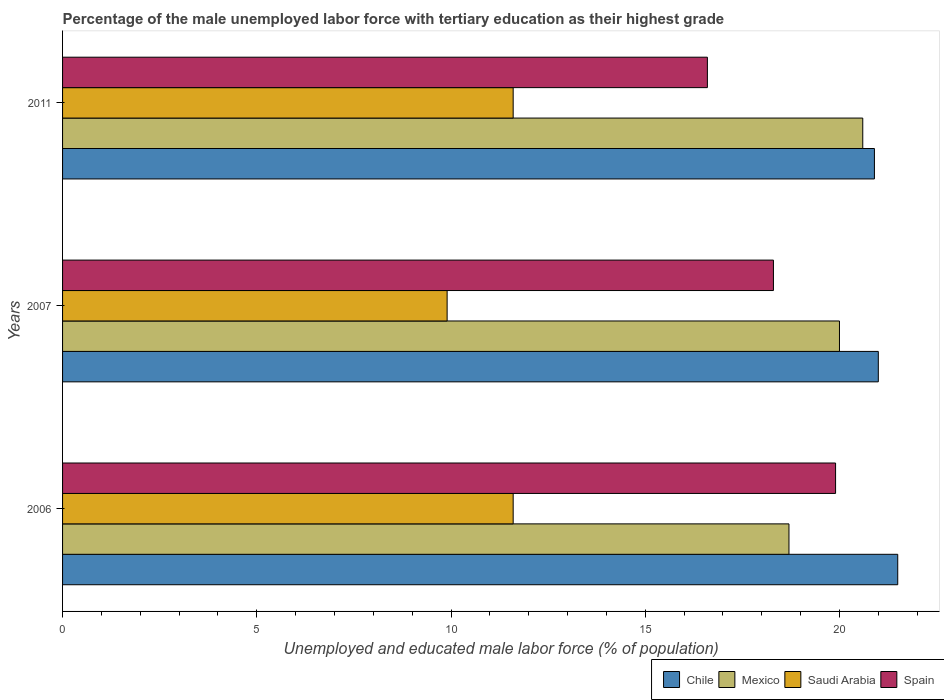How many groups of bars are there?
Provide a succinct answer. 3. Are the number of bars per tick equal to the number of legend labels?
Offer a terse response. Yes. Are the number of bars on each tick of the Y-axis equal?
Give a very brief answer. Yes. How many bars are there on the 1st tick from the bottom?
Provide a succinct answer. 4. In how many cases, is the number of bars for a given year not equal to the number of legend labels?
Provide a short and direct response. 0. What is the percentage of the unemployed male labor force with tertiary education in Mexico in 2006?
Offer a very short reply. 18.7. Across all years, what is the maximum percentage of the unemployed male labor force with tertiary education in Spain?
Your answer should be compact. 19.9. Across all years, what is the minimum percentage of the unemployed male labor force with tertiary education in Mexico?
Offer a terse response. 18.7. In which year was the percentage of the unemployed male labor force with tertiary education in Chile maximum?
Offer a very short reply. 2006. In which year was the percentage of the unemployed male labor force with tertiary education in Chile minimum?
Your answer should be compact. 2011. What is the total percentage of the unemployed male labor force with tertiary education in Saudi Arabia in the graph?
Provide a succinct answer. 33.1. What is the difference between the percentage of the unemployed male labor force with tertiary education in Saudi Arabia in 2007 and that in 2011?
Provide a short and direct response. -1.7. What is the difference between the percentage of the unemployed male labor force with tertiary education in Mexico in 2011 and the percentage of the unemployed male labor force with tertiary education in Spain in 2007?
Your answer should be compact. 2.3. What is the average percentage of the unemployed male labor force with tertiary education in Chile per year?
Provide a succinct answer. 21.13. What is the ratio of the percentage of the unemployed male labor force with tertiary education in Mexico in 2006 to that in 2011?
Keep it short and to the point. 0.91. Is the percentage of the unemployed male labor force with tertiary education in Saudi Arabia in 2007 less than that in 2011?
Offer a very short reply. Yes. Is the difference between the percentage of the unemployed male labor force with tertiary education in Chile in 2007 and 2011 greater than the difference between the percentage of the unemployed male labor force with tertiary education in Mexico in 2007 and 2011?
Offer a terse response. Yes. What is the difference between the highest and the second highest percentage of the unemployed male labor force with tertiary education in Spain?
Provide a short and direct response. 1.6. What is the difference between the highest and the lowest percentage of the unemployed male labor force with tertiary education in Spain?
Provide a succinct answer. 3.3. In how many years, is the percentage of the unemployed male labor force with tertiary education in Saudi Arabia greater than the average percentage of the unemployed male labor force with tertiary education in Saudi Arabia taken over all years?
Keep it short and to the point. 2. Is the sum of the percentage of the unemployed male labor force with tertiary education in Mexico in 2006 and 2011 greater than the maximum percentage of the unemployed male labor force with tertiary education in Spain across all years?
Give a very brief answer. Yes. What does the 4th bar from the top in 2006 represents?
Your response must be concise. Chile. What does the 4th bar from the bottom in 2011 represents?
Your response must be concise. Spain. How many bars are there?
Your answer should be very brief. 12. Are all the bars in the graph horizontal?
Make the answer very short. Yes. How many years are there in the graph?
Provide a succinct answer. 3. Does the graph contain any zero values?
Offer a very short reply. No. How many legend labels are there?
Provide a short and direct response. 4. What is the title of the graph?
Keep it short and to the point. Percentage of the male unemployed labor force with tertiary education as their highest grade. Does "Guinea" appear as one of the legend labels in the graph?
Your response must be concise. No. What is the label or title of the X-axis?
Your answer should be very brief. Unemployed and educated male labor force (% of population). What is the label or title of the Y-axis?
Ensure brevity in your answer.  Years. What is the Unemployed and educated male labor force (% of population) of Chile in 2006?
Your response must be concise. 21.5. What is the Unemployed and educated male labor force (% of population) of Mexico in 2006?
Offer a terse response. 18.7. What is the Unemployed and educated male labor force (% of population) of Saudi Arabia in 2006?
Your answer should be compact. 11.6. What is the Unemployed and educated male labor force (% of population) in Spain in 2006?
Your answer should be very brief. 19.9. What is the Unemployed and educated male labor force (% of population) of Mexico in 2007?
Provide a succinct answer. 20. What is the Unemployed and educated male labor force (% of population) in Saudi Arabia in 2007?
Make the answer very short. 9.9. What is the Unemployed and educated male labor force (% of population) in Spain in 2007?
Offer a terse response. 18.3. What is the Unemployed and educated male labor force (% of population) in Chile in 2011?
Your answer should be compact. 20.9. What is the Unemployed and educated male labor force (% of population) of Mexico in 2011?
Make the answer very short. 20.6. What is the Unemployed and educated male labor force (% of population) in Saudi Arabia in 2011?
Your answer should be very brief. 11.6. What is the Unemployed and educated male labor force (% of population) in Spain in 2011?
Ensure brevity in your answer.  16.6. Across all years, what is the maximum Unemployed and educated male labor force (% of population) in Mexico?
Your response must be concise. 20.6. Across all years, what is the maximum Unemployed and educated male labor force (% of population) in Saudi Arabia?
Offer a terse response. 11.6. Across all years, what is the maximum Unemployed and educated male labor force (% of population) of Spain?
Ensure brevity in your answer.  19.9. Across all years, what is the minimum Unemployed and educated male labor force (% of population) of Chile?
Ensure brevity in your answer.  20.9. Across all years, what is the minimum Unemployed and educated male labor force (% of population) of Mexico?
Your response must be concise. 18.7. Across all years, what is the minimum Unemployed and educated male labor force (% of population) in Saudi Arabia?
Offer a terse response. 9.9. Across all years, what is the minimum Unemployed and educated male labor force (% of population) of Spain?
Your answer should be compact. 16.6. What is the total Unemployed and educated male labor force (% of population) in Chile in the graph?
Keep it short and to the point. 63.4. What is the total Unemployed and educated male labor force (% of population) in Mexico in the graph?
Make the answer very short. 59.3. What is the total Unemployed and educated male labor force (% of population) of Saudi Arabia in the graph?
Keep it short and to the point. 33.1. What is the total Unemployed and educated male labor force (% of population) of Spain in the graph?
Offer a terse response. 54.8. What is the difference between the Unemployed and educated male labor force (% of population) of Chile in 2006 and that in 2007?
Keep it short and to the point. 0.5. What is the difference between the Unemployed and educated male labor force (% of population) in Mexico in 2006 and that in 2007?
Offer a very short reply. -1.3. What is the difference between the Unemployed and educated male labor force (% of population) in Spain in 2006 and that in 2007?
Offer a terse response. 1.6. What is the difference between the Unemployed and educated male labor force (% of population) of Chile in 2006 and that in 2011?
Offer a very short reply. 0.6. What is the difference between the Unemployed and educated male labor force (% of population) in Mexico in 2006 and that in 2011?
Your answer should be compact. -1.9. What is the difference between the Unemployed and educated male labor force (% of population) in Spain in 2006 and that in 2011?
Ensure brevity in your answer.  3.3. What is the difference between the Unemployed and educated male labor force (% of population) in Mexico in 2007 and that in 2011?
Your answer should be compact. -0.6. What is the difference between the Unemployed and educated male labor force (% of population) in Spain in 2007 and that in 2011?
Your answer should be compact. 1.7. What is the difference between the Unemployed and educated male labor force (% of population) of Chile in 2006 and the Unemployed and educated male labor force (% of population) of Mexico in 2007?
Give a very brief answer. 1.5. What is the difference between the Unemployed and educated male labor force (% of population) of Chile in 2006 and the Unemployed and educated male labor force (% of population) of Saudi Arabia in 2007?
Offer a terse response. 11.6. What is the difference between the Unemployed and educated male labor force (% of population) in Mexico in 2006 and the Unemployed and educated male labor force (% of population) in Saudi Arabia in 2007?
Your answer should be very brief. 8.8. What is the difference between the Unemployed and educated male labor force (% of population) in Chile in 2006 and the Unemployed and educated male labor force (% of population) in Saudi Arabia in 2011?
Your answer should be compact. 9.9. What is the difference between the Unemployed and educated male labor force (% of population) of Chile in 2006 and the Unemployed and educated male labor force (% of population) of Spain in 2011?
Keep it short and to the point. 4.9. What is the difference between the Unemployed and educated male labor force (% of population) in Mexico in 2006 and the Unemployed and educated male labor force (% of population) in Saudi Arabia in 2011?
Offer a terse response. 7.1. What is the difference between the Unemployed and educated male labor force (% of population) of Saudi Arabia in 2006 and the Unemployed and educated male labor force (% of population) of Spain in 2011?
Your answer should be compact. -5. What is the difference between the Unemployed and educated male labor force (% of population) in Chile in 2007 and the Unemployed and educated male labor force (% of population) in Spain in 2011?
Offer a very short reply. 4.4. What is the difference between the Unemployed and educated male labor force (% of population) of Mexico in 2007 and the Unemployed and educated male labor force (% of population) of Spain in 2011?
Keep it short and to the point. 3.4. What is the difference between the Unemployed and educated male labor force (% of population) of Saudi Arabia in 2007 and the Unemployed and educated male labor force (% of population) of Spain in 2011?
Your response must be concise. -6.7. What is the average Unemployed and educated male labor force (% of population) in Chile per year?
Provide a short and direct response. 21.13. What is the average Unemployed and educated male labor force (% of population) of Mexico per year?
Provide a short and direct response. 19.77. What is the average Unemployed and educated male labor force (% of population) of Saudi Arabia per year?
Provide a short and direct response. 11.03. What is the average Unemployed and educated male labor force (% of population) of Spain per year?
Provide a short and direct response. 18.27. In the year 2006, what is the difference between the Unemployed and educated male labor force (% of population) in Chile and Unemployed and educated male labor force (% of population) in Saudi Arabia?
Your answer should be very brief. 9.9. In the year 2006, what is the difference between the Unemployed and educated male labor force (% of population) in Chile and Unemployed and educated male labor force (% of population) in Spain?
Offer a very short reply. 1.6. In the year 2006, what is the difference between the Unemployed and educated male labor force (% of population) of Mexico and Unemployed and educated male labor force (% of population) of Saudi Arabia?
Offer a very short reply. 7.1. In the year 2006, what is the difference between the Unemployed and educated male labor force (% of population) in Mexico and Unemployed and educated male labor force (% of population) in Spain?
Your response must be concise. -1.2. In the year 2007, what is the difference between the Unemployed and educated male labor force (% of population) in Chile and Unemployed and educated male labor force (% of population) in Mexico?
Give a very brief answer. 1. In the year 2007, what is the difference between the Unemployed and educated male labor force (% of population) in Chile and Unemployed and educated male labor force (% of population) in Spain?
Provide a succinct answer. 2.7. In the year 2007, what is the difference between the Unemployed and educated male labor force (% of population) of Saudi Arabia and Unemployed and educated male labor force (% of population) of Spain?
Keep it short and to the point. -8.4. In the year 2011, what is the difference between the Unemployed and educated male labor force (% of population) in Chile and Unemployed and educated male labor force (% of population) in Saudi Arabia?
Keep it short and to the point. 9.3. In the year 2011, what is the difference between the Unemployed and educated male labor force (% of population) in Chile and Unemployed and educated male labor force (% of population) in Spain?
Your response must be concise. 4.3. In the year 2011, what is the difference between the Unemployed and educated male labor force (% of population) in Mexico and Unemployed and educated male labor force (% of population) in Saudi Arabia?
Provide a short and direct response. 9. In the year 2011, what is the difference between the Unemployed and educated male labor force (% of population) of Mexico and Unemployed and educated male labor force (% of population) of Spain?
Give a very brief answer. 4. What is the ratio of the Unemployed and educated male labor force (% of population) of Chile in 2006 to that in 2007?
Offer a terse response. 1.02. What is the ratio of the Unemployed and educated male labor force (% of population) in Mexico in 2006 to that in 2007?
Ensure brevity in your answer.  0.94. What is the ratio of the Unemployed and educated male labor force (% of population) of Saudi Arabia in 2006 to that in 2007?
Offer a terse response. 1.17. What is the ratio of the Unemployed and educated male labor force (% of population) in Spain in 2006 to that in 2007?
Give a very brief answer. 1.09. What is the ratio of the Unemployed and educated male labor force (% of population) in Chile in 2006 to that in 2011?
Make the answer very short. 1.03. What is the ratio of the Unemployed and educated male labor force (% of population) of Mexico in 2006 to that in 2011?
Your answer should be compact. 0.91. What is the ratio of the Unemployed and educated male labor force (% of population) in Spain in 2006 to that in 2011?
Ensure brevity in your answer.  1.2. What is the ratio of the Unemployed and educated male labor force (% of population) in Chile in 2007 to that in 2011?
Your answer should be very brief. 1. What is the ratio of the Unemployed and educated male labor force (% of population) of Mexico in 2007 to that in 2011?
Your response must be concise. 0.97. What is the ratio of the Unemployed and educated male labor force (% of population) of Saudi Arabia in 2007 to that in 2011?
Your answer should be very brief. 0.85. What is the ratio of the Unemployed and educated male labor force (% of population) in Spain in 2007 to that in 2011?
Keep it short and to the point. 1.1. What is the difference between the highest and the lowest Unemployed and educated male labor force (% of population) of Mexico?
Provide a short and direct response. 1.9. What is the difference between the highest and the lowest Unemployed and educated male labor force (% of population) of Spain?
Provide a short and direct response. 3.3. 